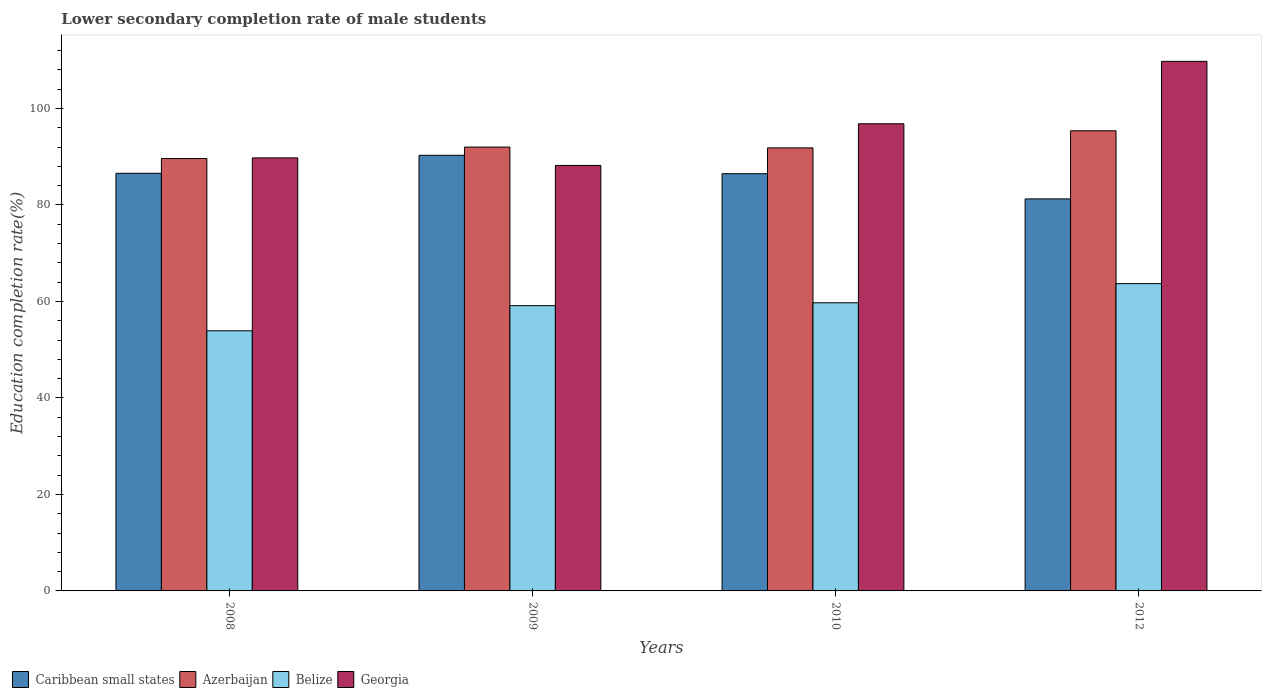How many groups of bars are there?
Your answer should be very brief. 4. Are the number of bars per tick equal to the number of legend labels?
Keep it short and to the point. Yes. Are the number of bars on each tick of the X-axis equal?
Offer a terse response. Yes. How many bars are there on the 2nd tick from the left?
Provide a succinct answer. 4. How many bars are there on the 1st tick from the right?
Offer a terse response. 4. What is the label of the 3rd group of bars from the left?
Offer a very short reply. 2010. What is the lower secondary completion rate of male students in Caribbean small states in 2012?
Your answer should be compact. 81.25. Across all years, what is the maximum lower secondary completion rate of male students in Belize?
Your answer should be compact. 63.69. Across all years, what is the minimum lower secondary completion rate of male students in Georgia?
Offer a terse response. 88.19. In which year was the lower secondary completion rate of male students in Azerbaijan maximum?
Your answer should be compact. 2012. In which year was the lower secondary completion rate of male students in Belize minimum?
Make the answer very short. 2008. What is the total lower secondary completion rate of male students in Azerbaijan in the graph?
Provide a succinct answer. 368.81. What is the difference between the lower secondary completion rate of male students in Georgia in 2009 and that in 2012?
Ensure brevity in your answer.  -21.57. What is the difference between the lower secondary completion rate of male students in Belize in 2010 and the lower secondary completion rate of male students in Georgia in 2009?
Give a very brief answer. -28.47. What is the average lower secondary completion rate of male students in Azerbaijan per year?
Keep it short and to the point. 92.2. In the year 2008, what is the difference between the lower secondary completion rate of male students in Georgia and lower secondary completion rate of male students in Azerbaijan?
Give a very brief answer. 0.13. In how many years, is the lower secondary completion rate of male students in Azerbaijan greater than 56 %?
Ensure brevity in your answer.  4. What is the ratio of the lower secondary completion rate of male students in Caribbean small states in 2009 to that in 2010?
Keep it short and to the point. 1.04. What is the difference between the highest and the second highest lower secondary completion rate of male students in Azerbaijan?
Provide a short and direct response. 3.38. What is the difference between the highest and the lowest lower secondary completion rate of male students in Azerbaijan?
Provide a short and direct response. 5.75. In how many years, is the lower secondary completion rate of male students in Azerbaijan greater than the average lower secondary completion rate of male students in Azerbaijan taken over all years?
Your answer should be compact. 1. What does the 1st bar from the left in 2008 represents?
Provide a succinct answer. Caribbean small states. What does the 1st bar from the right in 2008 represents?
Offer a very short reply. Georgia. What is the difference between two consecutive major ticks on the Y-axis?
Provide a short and direct response. 20. Are the values on the major ticks of Y-axis written in scientific E-notation?
Your answer should be compact. No. Where does the legend appear in the graph?
Ensure brevity in your answer.  Bottom left. What is the title of the graph?
Your response must be concise. Lower secondary completion rate of male students. Does "New Caledonia" appear as one of the legend labels in the graph?
Your answer should be compact. No. What is the label or title of the X-axis?
Provide a short and direct response. Years. What is the label or title of the Y-axis?
Offer a terse response. Education completion rate(%). What is the Education completion rate(%) in Caribbean small states in 2008?
Your answer should be very brief. 86.56. What is the Education completion rate(%) of Azerbaijan in 2008?
Your answer should be compact. 89.62. What is the Education completion rate(%) in Belize in 2008?
Provide a short and direct response. 53.91. What is the Education completion rate(%) in Georgia in 2008?
Your answer should be compact. 89.75. What is the Education completion rate(%) in Caribbean small states in 2009?
Your response must be concise. 90.29. What is the Education completion rate(%) of Azerbaijan in 2009?
Your answer should be compact. 91.99. What is the Education completion rate(%) of Belize in 2009?
Ensure brevity in your answer.  59.12. What is the Education completion rate(%) of Georgia in 2009?
Keep it short and to the point. 88.19. What is the Education completion rate(%) of Caribbean small states in 2010?
Offer a very short reply. 86.48. What is the Education completion rate(%) of Azerbaijan in 2010?
Provide a succinct answer. 91.83. What is the Education completion rate(%) in Belize in 2010?
Ensure brevity in your answer.  59.72. What is the Education completion rate(%) in Georgia in 2010?
Keep it short and to the point. 96.83. What is the Education completion rate(%) in Caribbean small states in 2012?
Offer a terse response. 81.25. What is the Education completion rate(%) in Azerbaijan in 2012?
Provide a succinct answer. 95.37. What is the Education completion rate(%) of Belize in 2012?
Provide a short and direct response. 63.69. What is the Education completion rate(%) of Georgia in 2012?
Give a very brief answer. 109.76. Across all years, what is the maximum Education completion rate(%) of Caribbean small states?
Offer a very short reply. 90.29. Across all years, what is the maximum Education completion rate(%) in Azerbaijan?
Offer a terse response. 95.37. Across all years, what is the maximum Education completion rate(%) of Belize?
Offer a very short reply. 63.69. Across all years, what is the maximum Education completion rate(%) in Georgia?
Offer a terse response. 109.76. Across all years, what is the minimum Education completion rate(%) in Caribbean small states?
Provide a short and direct response. 81.25. Across all years, what is the minimum Education completion rate(%) in Azerbaijan?
Make the answer very short. 89.62. Across all years, what is the minimum Education completion rate(%) in Belize?
Your response must be concise. 53.91. Across all years, what is the minimum Education completion rate(%) in Georgia?
Keep it short and to the point. 88.19. What is the total Education completion rate(%) of Caribbean small states in the graph?
Make the answer very short. 344.58. What is the total Education completion rate(%) in Azerbaijan in the graph?
Your answer should be very brief. 368.81. What is the total Education completion rate(%) of Belize in the graph?
Your answer should be compact. 236.44. What is the total Education completion rate(%) in Georgia in the graph?
Give a very brief answer. 384.52. What is the difference between the Education completion rate(%) of Caribbean small states in 2008 and that in 2009?
Provide a succinct answer. -3.73. What is the difference between the Education completion rate(%) in Azerbaijan in 2008 and that in 2009?
Your answer should be very brief. -2.37. What is the difference between the Education completion rate(%) in Belize in 2008 and that in 2009?
Your answer should be compact. -5.21. What is the difference between the Education completion rate(%) of Georgia in 2008 and that in 2009?
Offer a very short reply. 1.56. What is the difference between the Education completion rate(%) of Caribbean small states in 2008 and that in 2010?
Offer a very short reply. 0.08. What is the difference between the Education completion rate(%) in Azerbaijan in 2008 and that in 2010?
Your answer should be compact. -2.21. What is the difference between the Education completion rate(%) of Belize in 2008 and that in 2010?
Keep it short and to the point. -5.8. What is the difference between the Education completion rate(%) in Georgia in 2008 and that in 2010?
Offer a terse response. -7.08. What is the difference between the Education completion rate(%) of Caribbean small states in 2008 and that in 2012?
Ensure brevity in your answer.  5.31. What is the difference between the Education completion rate(%) in Azerbaijan in 2008 and that in 2012?
Your answer should be very brief. -5.75. What is the difference between the Education completion rate(%) in Belize in 2008 and that in 2012?
Offer a terse response. -9.77. What is the difference between the Education completion rate(%) in Georgia in 2008 and that in 2012?
Provide a short and direct response. -20.01. What is the difference between the Education completion rate(%) in Caribbean small states in 2009 and that in 2010?
Give a very brief answer. 3.81. What is the difference between the Education completion rate(%) of Azerbaijan in 2009 and that in 2010?
Your answer should be very brief. 0.17. What is the difference between the Education completion rate(%) in Belize in 2009 and that in 2010?
Provide a short and direct response. -0.6. What is the difference between the Education completion rate(%) of Georgia in 2009 and that in 2010?
Give a very brief answer. -8.64. What is the difference between the Education completion rate(%) of Caribbean small states in 2009 and that in 2012?
Offer a terse response. 9.04. What is the difference between the Education completion rate(%) of Azerbaijan in 2009 and that in 2012?
Provide a short and direct response. -3.38. What is the difference between the Education completion rate(%) in Belize in 2009 and that in 2012?
Make the answer very short. -4.56. What is the difference between the Education completion rate(%) in Georgia in 2009 and that in 2012?
Make the answer very short. -21.57. What is the difference between the Education completion rate(%) in Caribbean small states in 2010 and that in 2012?
Keep it short and to the point. 5.22. What is the difference between the Education completion rate(%) in Azerbaijan in 2010 and that in 2012?
Your answer should be compact. -3.55. What is the difference between the Education completion rate(%) of Belize in 2010 and that in 2012?
Give a very brief answer. -3.97. What is the difference between the Education completion rate(%) in Georgia in 2010 and that in 2012?
Give a very brief answer. -12.93. What is the difference between the Education completion rate(%) in Caribbean small states in 2008 and the Education completion rate(%) in Azerbaijan in 2009?
Ensure brevity in your answer.  -5.43. What is the difference between the Education completion rate(%) in Caribbean small states in 2008 and the Education completion rate(%) in Belize in 2009?
Your answer should be compact. 27.44. What is the difference between the Education completion rate(%) in Caribbean small states in 2008 and the Education completion rate(%) in Georgia in 2009?
Your answer should be compact. -1.62. What is the difference between the Education completion rate(%) in Azerbaijan in 2008 and the Education completion rate(%) in Belize in 2009?
Offer a terse response. 30.5. What is the difference between the Education completion rate(%) of Azerbaijan in 2008 and the Education completion rate(%) of Georgia in 2009?
Your response must be concise. 1.43. What is the difference between the Education completion rate(%) in Belize in 2008 and the Education completion rate(%) in Georgia in 2009?
Your answer should be compact. -34.27. What is the difference between the Education completion rate(%) in Caribbean small states in 2008 and the Education completion rate(%) in Azerbaijan in 2010?
Give a very brief answer. -5.27. What is the difference between the Education completion rate(%) in Caribbean small states in 2008 and the Education completion rate(%) in Belize in 2010?
Make the answer very short. 26.84. What is the difference between the Education completion rate(%) in Caribbean small states in 2008 and the Education completion rate(%) in Georgia in 2010?
Ensure brevity in your answer.  -10.27. What is the difference between the Education completion rate(%) in Azerbaijan in 2008 and the Education completion rate(%) in Belize in 2010?
Your answer should be compact. 29.9. What is the difference between the Education completion rate(%) in Azerbaijan in 2008 and the Education completion rate(%) in Georgia in 2010?
Give a very brief answer. -7.21. What is the difference between the Education completion rate(%) of Belize in 2008 and the Education completion rate(%) of Georgia in 2010?
Your response must be concise. -42.91. What is the difference between the Education completion rate(%) of Caribbean small states in 2008 and the Education completion rate(%) of Azerbaijan in 2012?
Offer a terse response. -8.81. What is the difference between the Education completion rate(%) in Caribbean small states in 2008 and the Education completion rate(%) in Belize in 2012?
Your answer should be compact. 22.88. What is the difference between the Education completion rate(%) in Caribbean small states in 2008 and the Education completion rate(%) in Georgia in 2012?
Give a very brief answer. -23.2. What is the difference between the Education completion rate(%) of Azerbaijan in 2008 and the Education completion rate(%) of Belize in 2012?
Offer a very short reply. 25.93. What is the difference between the Education completion rate(%) of Azerbaijan in 2008 and the Education completion rate(%) of Georgia in 2012?
Offer a very short reply. -20.14. What is the difference between the Education completion rate(%) of Belize in 2008 and the Education completion rate(%) of Georgia in 2012?
Provide a short and direct response. -55.85. What is the difference between the Education completion rate(%) of Caribbean small states in 2009 and the Education completion rate(%) of Azerbaijan in 2010?
Provide a short and direct response. -1.54. What is the difference between the Education completion rate(%) in Caribbean small states in 2009 and the Education completion rate(%) in Belize in 2010?
Keep it short and to the point. 30.57. What is the difference between the Education completion rate(%) in Caribbean small states in 2009 and the Education completion rate(%) in Georgia in 2010?
Ensure brevity in your answer.  -6.54. What is the difference between the Education completion rate(%) in Azerbaijan in 2009 and the Education completion rate(%) in Belize in 2010?
Your answer should be very brief. 32.28. What is the difference between the Education completion rate(%) of Azerbaijan in 2009 and the Education completion rate(%) of Georgia in 2010?
Provide a succinct answer. -4.83. What is the difference between the Education completion rate(%) of Belize in 2009 and the Education completion rate(%) of Georgia in 2010?
Give a very brief answer. -37.7. What is the difference between the Education completion rate(%) in Caribbean small states in 2009 and the Education completion rate(%) in Azerbaijan in 2012?
Your response must be concise. -5.08. What is the difference between the Education completion rate(%) in Caribbean small states in 2009 and the Education completion rate(%) in Belize in 2012?
Provide a succinct answer. 26.61. What is the difference between the Education completion rate(%) of Caribbean small states in 2009 and the Education completion rate(%) of Georgia in 2012?
Your answer should be very brief. -19.47. What is the difference between the Education completion rate(%) in Azerbaijan in 2009 and the Education completion rate(%) in Belize in 2012?
Provide a succinct answer. 28.31. What is the difference between the Education completion rate(%) of Azerbaijan in 2009 and the Education completion rate(%) of Georgia in 2012?
Give a very brief answer. -17.77. What is the difference between the Education completion rate(%) of Belize in 2009 and the Education completion rate(%) of Georgia in 2012?
Provide a short and direct response. -50.64. What is the difference between the Education completion rate(%) in Caribbean small states in 2010 and the Education completion rate(%) in Azerbaijan in 2012?
Ensure brevity in your answer.  -8.9. What is the difference between the Education completion rate(%) in Caribbean small states in 2010 and the Education completion rate(%) in Belize in 2012?
Ensure brevity in your answer.  22.79. What is the difference between the Education completion rate(%) in Caribbean small states in 2010 and the Education completion rate(%) in Georgia in 2012?
Give a very brief answer. -23.28. What is the difference between the Education completion rate(%) of Azerbaijan in 2010 and the Education completion rate(%) of Belize in 2012?
Your answer should be very brief. 28.14. What is the difference between the Education completion rate(%) in Azerbaijan in 2010 and the Education completion rate(%) in Georgia in 2012?
Provide a short and direct response. -17.93. What is the difference between the Education completion rate(%) in Belize in 2010 and the Education completion rate(%) in Georgia in 2012?
Make the answer very short. -50.04. What is the average Education completion rate(%) in Caribbean small states per year?
Make the answer very short. 86.15. What is the average Education completion rate(%) in Azerbaijan per year?
Ensure brevity in your answer.  92.2. What is the average Education completion rate(%) in Belize per year?
Provide a short and direct response. 59.11. What is the average Education completion rate(%) in Georgia per year?
Provide a short and direct response. 96.13. In the year 2008, what is the difference between the Education completion rate(%) in Caribbean small states and Education completion rate(%) in Azerbaijan?
Offer a terse response. -3.06. In the year 2008, what is the difference between the Education completion rate(%) of Caribbean small states and Education completion rate(%) of Belize?
Your answer should be very brief. 32.65. In the year 2008, what is the difference between the Education completion rate(%) in Caribbean small states and Education completion rate(%) in Georgia?
Provide a succinct answer. -3.19. In the year 2008, what is the difference between the Education completion rate(%) of Azerbaijan and Education completion rate(%) of Belize?
Your response must be concise. 35.7. In the year 2008, what is the difference between the Education completion rate(%) in Azerbaijan and Education completion rate(%) in Georgia?
Give a very brief answer. -0.13. In the year 2008, what is the difference between the Education completion rate(%) in Belize and Education completion rate(%) in Georgia?
Provide a succinct answer. -35.83. In the year 2009, what is the difference between the Education completion rate(%) in Caribbean small states and Education completion rate(%) in Azerbaijan?
Provide a succinct answer. -1.7. In the year 2009, what is the difference between the Education completion rate(%) of Caribbean small states and Education completion rate(%) of Belize?
Your answer should be compact. 31.17. In the year 2009, what is the difference between the Education completion rate(%) in Caribbean small states and Education completion rate(%) in Georgia?
Offer a terse response. 2.11. In the year 2009, what is the difference between the Education completion rate(%) of Azerbaijan and Education completion rate(%) of Belize?
Ensure brevity in your answer.  32.87. In the year 2009, what is the difference between the Education completion rate(%) in Azerbaijan and Education completion rate(%) in Georgia?
Your response must be concise. 3.81. In the year 2009, what is the difference between the Education completion rate(%) of Belize and Education completion rate(%) of Georgia?
Ensure brevity in your answer.  -29.06. In the year 2010, what is the difference between the Education completion rate(%) of Caribbean small states and Education completion rate(%) of Azerbaijan?
Keep it short and to the point. -5.35. In the year 2010, what is the difference between the Education completion rate(%) of Caribbean small states and Education completion rate(%) of Belize?
Provide a succinct answer. 26.76. In the year 2010, what is the difference between the Education completion rate(%) in Caribbean small states and Education completion rate(%) in Georgia?
Provide a short and direct response. -10.35. In the year 2010, what is the difference between the Education completion rate(%) in Azerbaijan and Education completion rate(%) in Belize?
Your answer should be compact. 32.11. In the year 2010, what is the difference between the Education completion rate(%) in Belize and Education completion rate(%) in Georgia?
Offer a very short reply. -37.11. In the year 2012, what is the difference between the Education completion rate(%) in Caribbean small states and Education completion rate(%) in Azerbaijan?
Give a very brief answer. -14.12. In the year 2012, what is the difference between the Education completion rate(%) in Caribbean small states and Education completion rate(%) in Belize?
Offer a very short reply. 17.57. In the year 2012, what is the difference between the Education completion rate(%) of Caribbean small states and Education completion rate(%) of Georgia?
Your answer should be very brief. -28.51. In the year 2012, what is the difference between the Education completion rate(%) of Azerbaijan and Education completion rate(%) of Belize?
Keep it short and to the point. 31.69. In the year 2012, what is the difference between the Education completion rate(%) of Azerbaijan and Education completion rate(%) of Georgia?
Provide a short and direct response. -14.39. In the year 2012, what is the difference between the Education completion rate(%) of Belize and Education completion rate(%) of Georgia?
Offer a terse response. -46.07. What is the ratio of the Education completion rate(%) in Caribbean small states in 2008 to that in 2009?
Your response must be concise. 0.96. What is the ratio of the Education completion rate(%) of Azerbaijan in 2008 to that in 2009?
Provide a short and direct response. 0.97. What is the ratio of the Education completion rate(%) of Belize in 2008 to that in 2009?
Your answer should be very brief. 0.91. What is the ratio of the Education completion rate(%) in Georgia in 2008 to that in 2009?
Provide a succinct answer. 1.02. What is the ratio of the Education completion rate(%) of Caribbean small states in 2008 to that in 2010?
Your answer should be compact. 1. What is the ratio of the Education completion rate(%) in Belize in 2008 to that in 2010?
Give a very brief answer. 0.9. What is the ratio of the Education completion rate(%) of Georgia in 2008 to that in 2010?
Ensure brevity in your answer.  0.93. What is the ratio of the Education completion rate(%) in Caribbean small states in 2008 to that in 2012?
Your answer should be very brief. 1.07. What is the ratio of the Education completion rate(%) in Azerbaijan in 2008 to that in 2012?
Keep it short and to the point. 0.94. What is the ratio of the Education completion rate(%) of Belize in 2008 to that in 2012?
Offer a terse response. 0.85. What is the ratio of the Education completion rate(%) in Georgia in 2008 to that in 2012?
Give a very brief answer. 0.82. What is the ratio of the Education completion rate(%) in Caribbean small states in 2009 to that in 2010?
Provide a succinct answer. 1.04. What is the ratio of the Education completion rate(%) of Belize in 2009 to that in 2010?
Give a very brief answer. 0.99. What is the ratio of the Education completion rate(%) in Georgia in 2009 to that in 2010?
Your answer should be very brief. 0.91. What is the ratio of the Education completion rate(%) of Caribbean small states in 2009 to that in 2012?
Your answer should be very brief. 1.11. What is the ratio of the Education completion rate(%) in Azerbaijan in 2009 to that in 2012?
Your response must be concise. 0.96. What is the ratio of the Education completion rate(%) in Belize in 2009 to that in 2012?
Provide a short and direct response. 0.93. What is the ratio of the Education completion rate(%) in Georgia in 2009 to that in 2012?
Provide a short and direct response. 0.8. What is the ratio of the Education completion rate(%) of Caribbean small states in 2010 to that in 2012?
Offer a terse response. 1.06. What is the ratio of the Education completion rate(%) in Azerbaijan in 2010 to that in 2012?
Make the answer very short. 0.96. What is the ratio of the Education completion rate(%) of Belize in 2010 to that in 2012?
Keep it short and to the point. 0.94. What is the ratio of the Education completion rate(%) of Georgia in 2010 to that in 2012?
Your response must be concise. 0.88. What is the difference between the highest and the second highest Education completion rate(%) in Caribbean small states?
Provide a short and direct response. 3.73. What is the difference between the highest and the second highest Education completion rate(%) of Azerbaijan?
Provide a short and direct response. 3.38. What is the difference between the highest and the second highest Education completion rate(%) in Belize?
Make the answer very short. 3.97. What is the difference between the highest and the second highest Education completion rate(%) of Georgia?
Offer a terse response. 12.93. What is the difference between the highest and the lowest Education completion rate(%) of Caribbean small states?
Provide a succinct answer. 9.04. What is the difference between the highest and the lowest Education completion rate(%) of Azerbaijan?
Offer a terse response. 5.75. What is the difference between the highest and the lowest Education completion rate(%) in Belize?
Make the answer very short. 9.77. What is the difference between the highest and the lowest Education completion rate(%) in Georgia?
Your answer should be very brief. 21.57. 